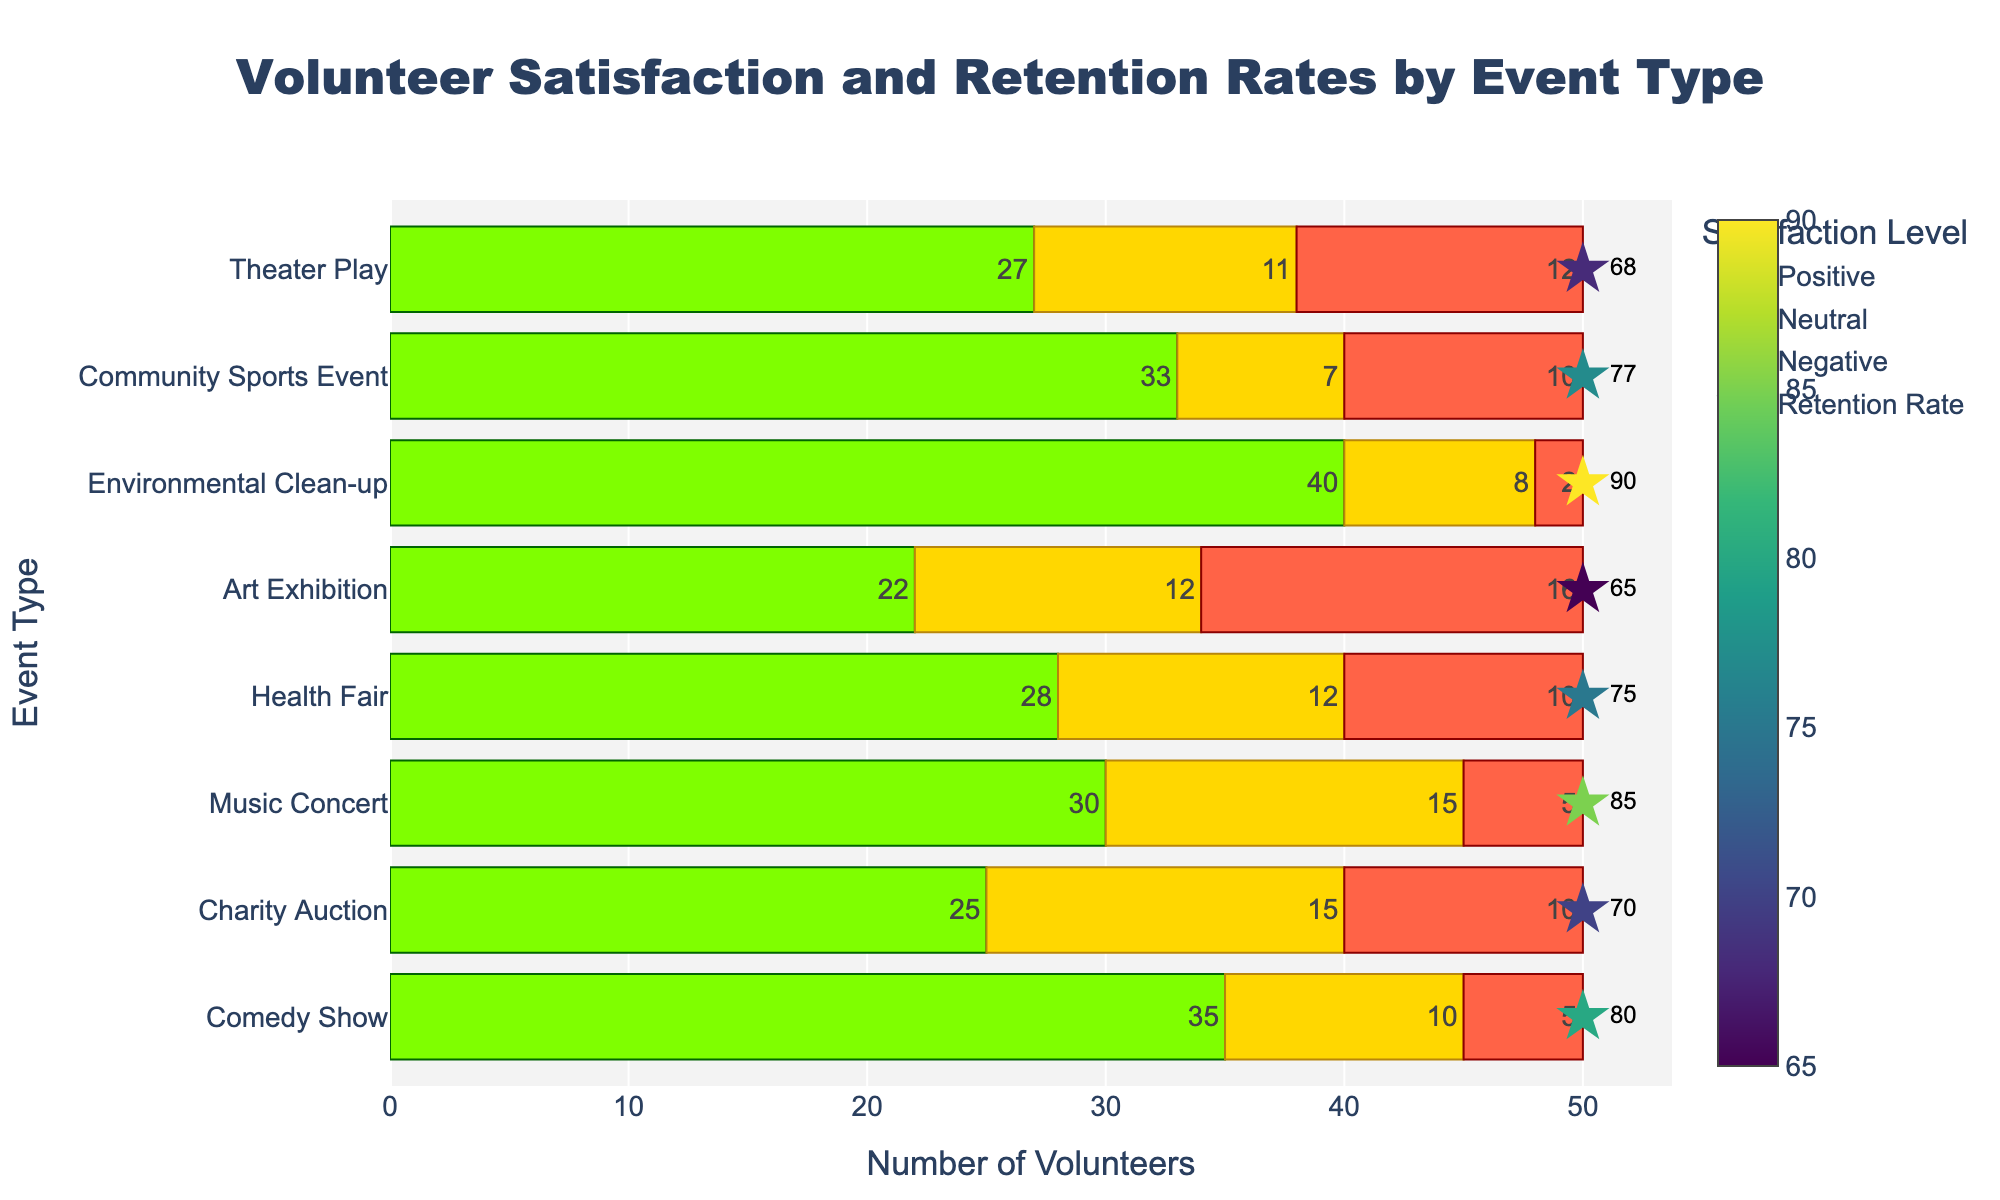Which event type has the highest retention rate? Look for the event type with the largest retention rate number shown next to the stars. The Environmental Clean-up event has the highest retention rate of 90%.
Answer: Environmental Clean-up Which event type has the most significant number of volunteers with positive satisfaction? Compare the length of the green bars representing positive satisfaction for each event type. The Environmental Clean-up event has the longest green bar, indicating 40 volunteers with positive satisfaction.
Answer: Environmental Clean-up Which event type has the highest number of volunteers with negative satisfaction? Look for the event type with the largest red bar, which represents negative satisfaction. The Art Exhibition event shows the longest red bar with 16 volunteers having negative satisfaction.
Answer: Art Exhibition Which two events have the closest retention rates? Observe and compare the retention rate stars next to each event. The Comedy Show and Music Concert events have retention rates of 80% and 85%, respectively, which are close in value.
Answer: Comedy Show and Music Concert What's the average retention rate of all event types? First sum up all the retention rates: 80 + 70 + 85 + 75 + 65 + 90 + 77 + 68 = 610. Then, divide by the number of events, which is 8. Therefore, the average retention rate is 610 / 8 = 76.25.
Answer: 76.25 In which event type is the neutral satisfaction rate equal to the negative satisfaction rate, and what event type is it? Identify the event type where the yellow bar (neutral satisfaction) is equal in length to the red bar (negative satisfaction). In the Health Fair event, both bars have length 12.
Answer: Health Fair Which event types have a higher neutral satisfaction rate than positive satisfaction rate? Compare the yellow bars (neutral) to the green bars (positive) for each event type. No event type has a higher neutral satisfaction rate than positive satisfaction rate.
Answer: None What is the combined number of volunteers with positive satisfaction for the Theater Play and the Charity Auction? Sum the number of volunteers with positive satisfaction for both events: Theater Play (27) + Charity Auction (25) = 52.
Answer: 52 Which event type has the lowest retention rate? Look for the event type with the smallest retention rate number next to the stars. The Art Exhibition has the lowest retention rate with 65%.
Answer: Art Exhibition 